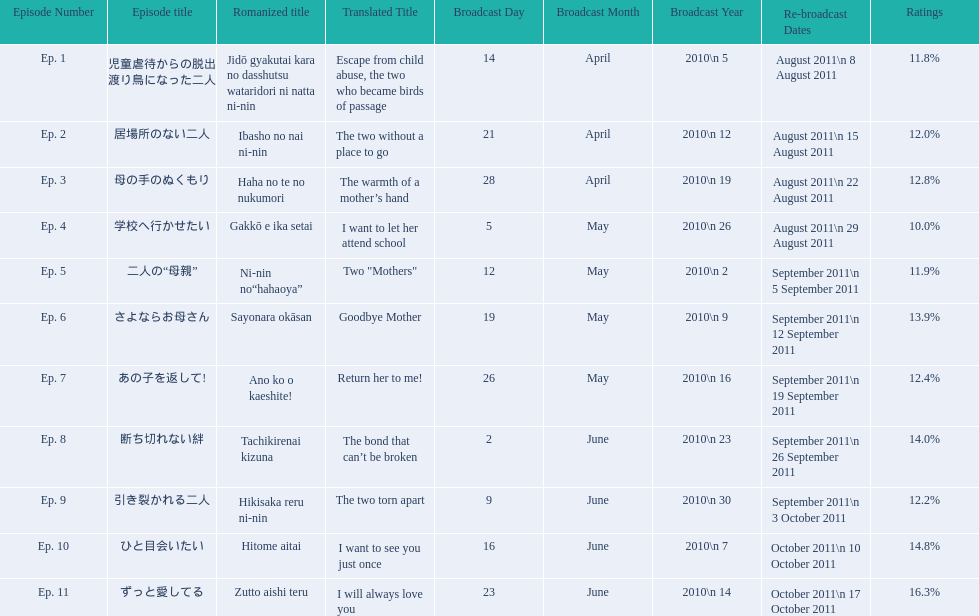What were the episode titles of mother? 児童虐待からの脱出 渡り鳥になった二人, 居場所のない二人, 母の手のぬくもり, 学校へ行かせたい, 二人の“母親”, さよならお母さん, あの子を返して!, 断ち切れない絆, 引き裂かれる二人, ひと目会いたい, ずっと愛してる. Which of these episodes had the highest ratings? ずっと愛してる. 